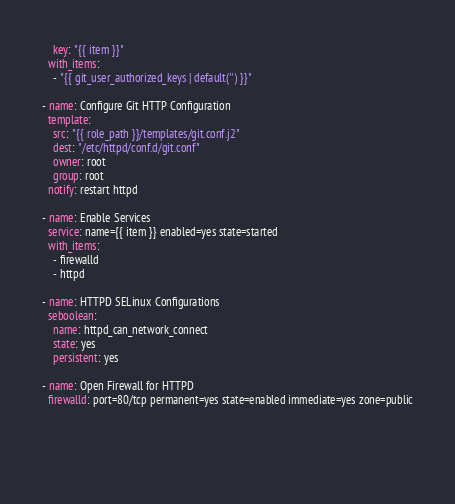<code> <loc_0><loc_0><loc_500><loc_500><_YAML_>    key: "{{ item }}"
  with_items:
    - "{{ git_user_authorized_keys | default('') }}"
  
- name: Configure Git HTTP Configuration
  template:
    src: "{{ role_path }}/templates/git.conf.j2"
    dest: "/etc/httpd/conf.d/git.conf"
    owner: root
    group: root
  notify: restart httpd

- name: Enable Services
  service: name={{ item }} enabled=yes state=started   
  with_items:
    - firewalld
    - httpd 
    
- name: HTTPD SELinux Configurations
  seboolean: 
    name: httpd_can_network_connect
    state: yes
    persistent: yes

- name: Open Firewall for HTTPD
  firewalld: port=80/tcp permanent=yes state=enabled immediate=yes zone=public
  


 
</code> 